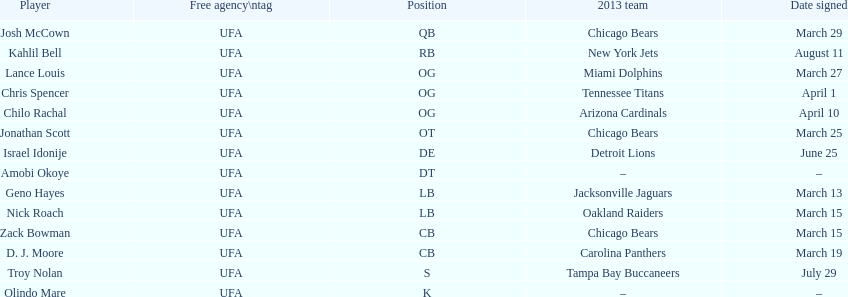Geno hayes and nick roach both played which position? LB. Would you be able to parse every entry in this table? {'header': ['Player', 'Free agency\\ntag', 'Position', '2013 team', 'Date signed'], 'rows': [['Josh McCown', 'UFA', 'QB', 'Chicago Bears', 'March 29'], ['Kahlil Bell', 'UFA', 'RB', 'New York Jets', 'August 11'], ['Lance Louis', 'UFA', 'OG', 'Miami Dolphins', 'March 27'], ['Chris Spencer', 'UFA', 'OG', 'Tennessee Titans', 'April 1'], ['Chilo Rachal', 'UFA', 'OG', 'Arizona Cardinals', 'April 10'], ['Jonathan Scott', 'UFA', 'OT', 'Chicago Bears', 'March 25'], ['Israel Idonije', 'UFA', 'DE', 'Detroit Lions', 'June 25'], ['Amobi Okoye', 'UFA', 'DT', '–', '–'], ['Geno Hayes', 'UFA', 'LB', 'Jacksonville Jaguars', 'March 13'], ['Nick Roach', 'UFA', 'LB', 'Oakland Raiders', 'March 15'], ['Zack Bowman', 'UFA', 'CB', 'Chicago Bears', 'March 15'], ['D. J. Moore', 'UFA', 'CB', 'Carolina Panthers', 'March 19'], ['Troy Nolan', 'UFA', 'S', 'Tampa Bay Buccaneers', 'July 29'], ['Olindo Mare', 'UFA', 'K', '–', '–']]} 